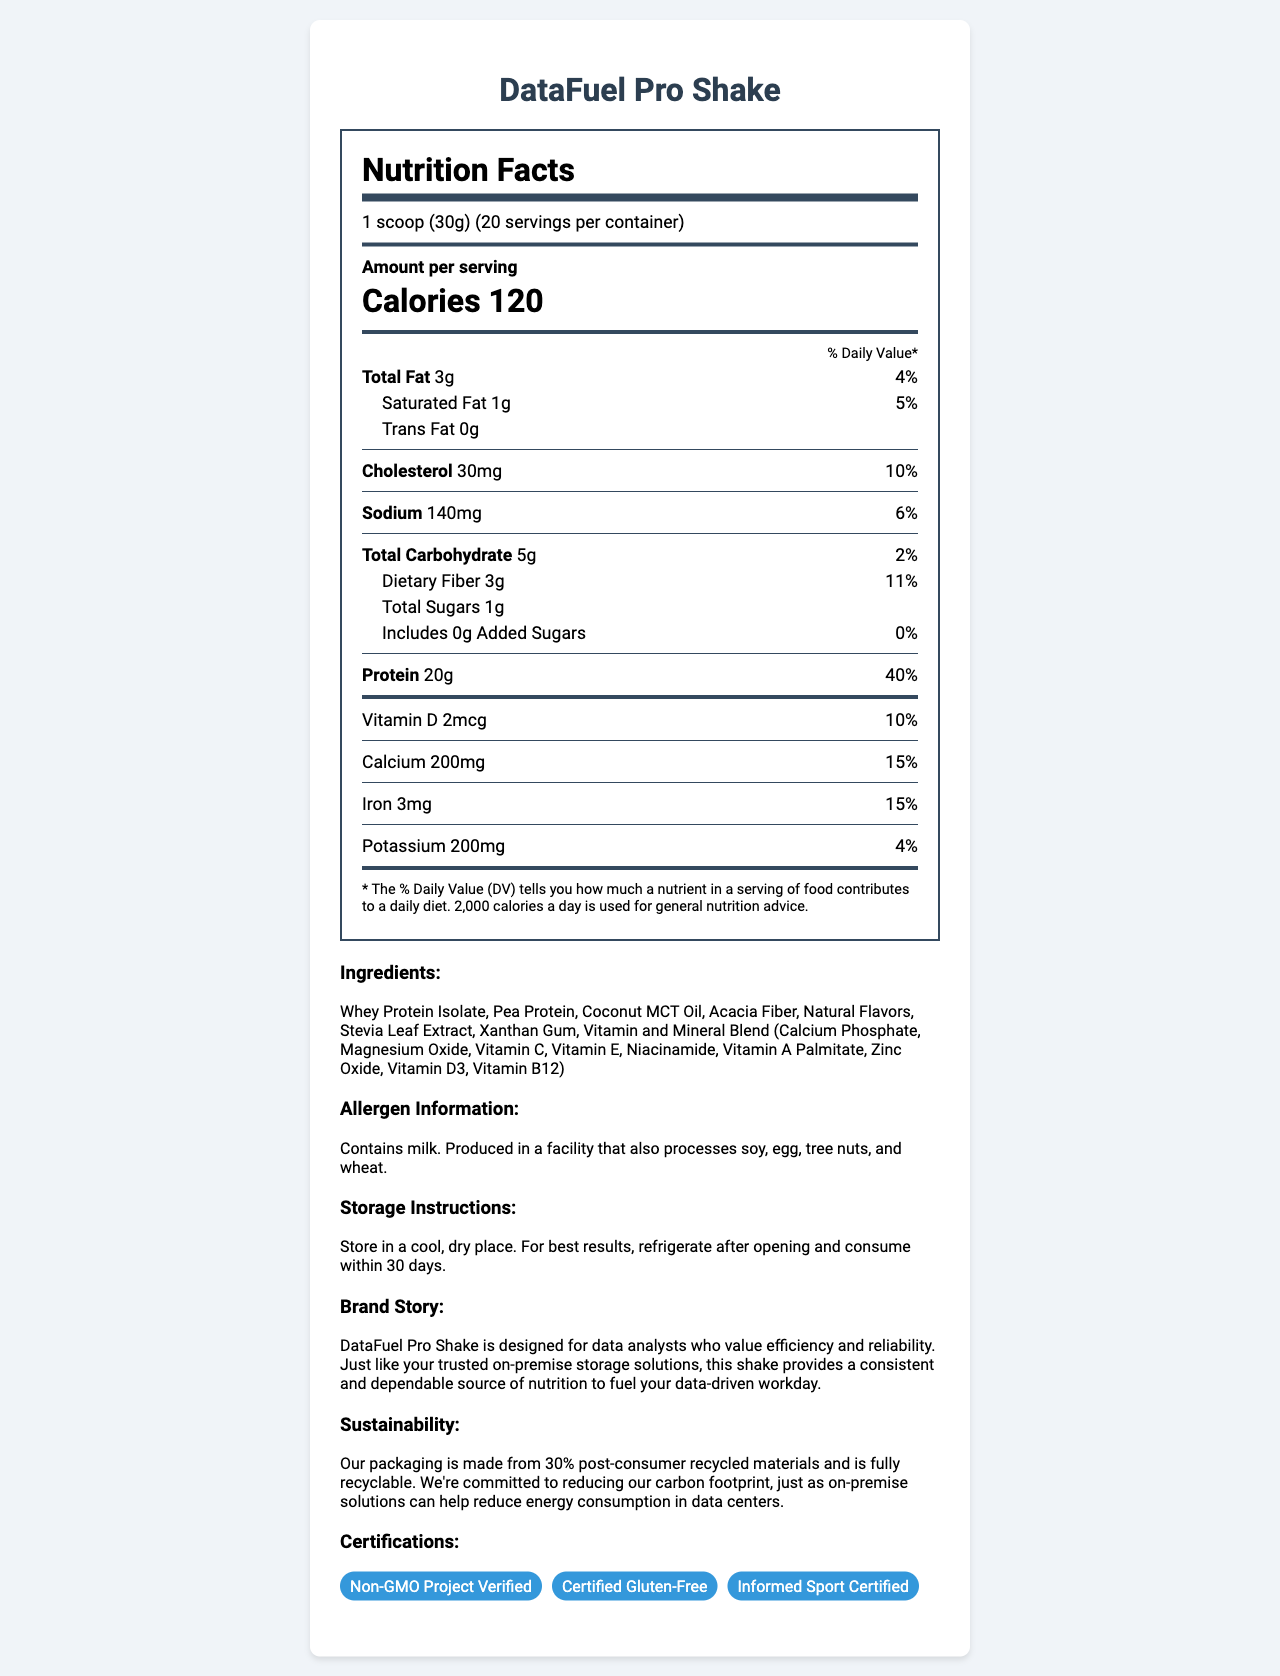what is the calories per serving for DataFuel Pro Shake? The document states that there are 120 calories per serving.
Answer: 120 how much total fat is in each serving? The nutrition label lists "Total Fat" as 3g per serving.
Answer: 3g what percentage of the daily value is the protein content? The label shows that the protein content is 40% of the daily value.
Answer: 40% how many grams of dietary fiber are included in each serving? Dietary Fiber is listed as 3g per serving on the nutrition label.
Answer: 3g how many servings per container are there? The document specifies that there are 20 servings per container.
Answer: 20 which ingredient is used as a sweetener? A. Pea Protein B. Stevia Leaf Extract C. Xanthan Gum D. Natural Flavors The ingredient list includes "Stevia Leaf Extract" as a natural sweetener.
Answer: B what is the amount of cholesterol per serving? A. 10mg B. 20mg C. 30mg D. 40mg The nutrition facts show that cholesterol per serving is 30mg.
Answer: C is the DataFuel Pro Shake certified gluten-free? The document lists "Certified Gluten-Free" under its certifications.
Answer: Yes describe the allergen information for DataFuel Pro Shake The allergen information specifies that the product contains milk and is produced in a facility that also processes soy, egg, tree nuts, and wheat.
Answer: Contains milk. Produced in a facility that also processes soy, egg, tree nuts, and wheat. which vitamins and minerals blend is included in the ingredients? The ingredients list specifies the vitamins and minerals blend.
Answer: Calcium Phosphate, Magnesium Oxide, Vitamin C, Vitamin E, Niacinamide, Vitamin A Palmitate, Zinc Oxide, Vitamin D3, Vitamin B12 what is the serving size of DataFuel Pro Shake? The document mentions that the serving size is 1 scoop (30g).
Answer: 1 scoop (30g) what is the total amount of sugars per serving? The total sugars listed in the nutrition facts is 1g per serving.
Answer: 1g what is the main goal of DataFuel Pro Shake according to the brand story? The brand story states that the shake is designed for data analysts to provide a consistent and dependable source of nutrition.
Answer: To provide a consistent and dependable source of nutrition to fuel data analysts' workdays. explain the sustainability efforts mentioned in the document The document mentions that the packaging uses recycled materials and is recyclable, showcasing the company’s efforts in sustainability.
Answer: The packaging is made from 30% post-consumer recycled materials and is fully recyclable. The company is committed to reducing its carbon footprint. what kind of storage instructions are given for the DataFuel Pro Shake? The document outlines these instructions for optimal storage and use of the product.
Answer: Store in a cool, dry place. Refrigerate after opening and consume within 30 days. what is the level of potassium per serving? The nutrition label indicates that the potassium content is 200mg per serving.
Answer: 200mg why is the DataFuel Pro Shake suitable for data analysts? The brand story highlights that the shake is designed to be a reliable source of nutrition for data analysts.
Answer: It provides efficient and reliable nutrition to fuel their data-driven workday. how many different types of certifications does DataFuel Pro Shake have? The document lists three certifications: Non-GMO Project Verified, Certified Gluten-Free, and Informed Sport Certified.
Answer: Three which vitamin contributes to 10% of the daily value per serving? The nutrition facts show Vitamin D providing 10% of the daily value per serving.
Answer: Vitamin D how much added sugars are in DataFuel Pro Shake? The document states there are 0g of added sugars in the shake.
Answer: 0g what is the protein source in DataFuel Pro Shake? The ingredients list indicates that the protein sources are Whey Protein Isolate and Pea Protein.
Answer: Whey Protein Isolate and Pea Protein how does the company aim to reduce energy consumption according to the sustainability info? The document does not provide detailed information on how the company specifically aims to reduce energy consumption outside of packaging efforts.
Answer: Not enough information 